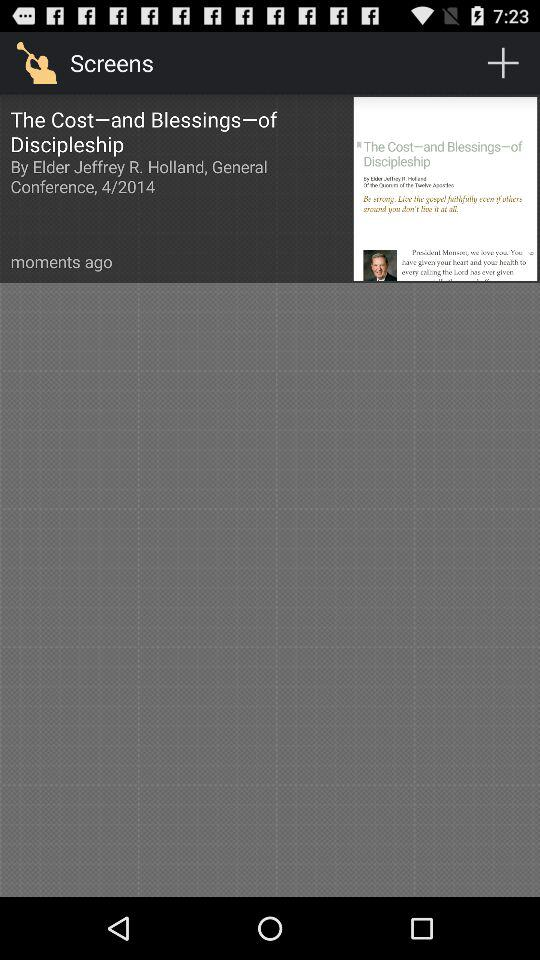What is the application name? The application name is "Screens". 